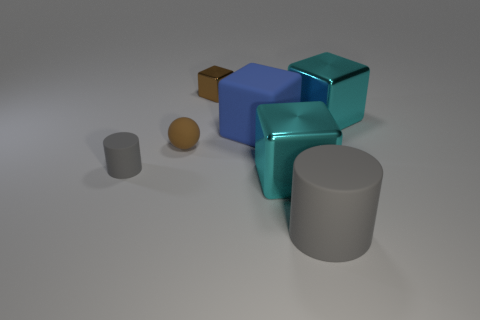Do the small cube and the sphere have the same color?
Keep it short and to the point. Yes. What shape is the brown object that is the same material as the large blue object?
Offer a terse response. Sphere. Is there any other thing that has the same color as the big matte block?
Ensure brevity in your answer.  No. What material is the tiny brown object that is the same shape as the large blue object?
Provide a short and direct response. Metal. How many other objects are there of the same size as the brown ball?
Make the answer very short. 2. What size is the matte thing that is the same color as the large cylinder?
Your answer should be very brief. Small. There is a blue rubber thing right of the brown matte thing; is its shape the same as the brown metallic thing?
Give a very brief answer. Yes. What number of other objects are there of the same shape as the tiny brown matte object?
Offer a terse response. 0. What is the shape of the big matte object behind the ball?
Your answer should be very brief. Cube. Are there any small cyan spheres that have the same material as the tiny block?
Your response must be concise. No. 